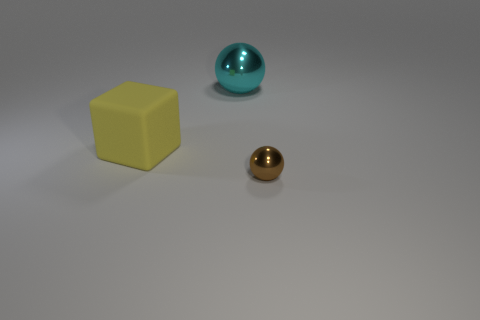Add 3 matte cubes. How many objects exist? 6 Subtract all balls. How many objects are left? 1 Add 3 large red cylinders. How many large red cylinders exist? 3 Subtract 0 blue cylinders. How many objects are left? 3 Subtract all gray blocks. Subtract all big rubber things. How many objects are left? 2 Add 1 small brown things. How many small brown things are left? 2 